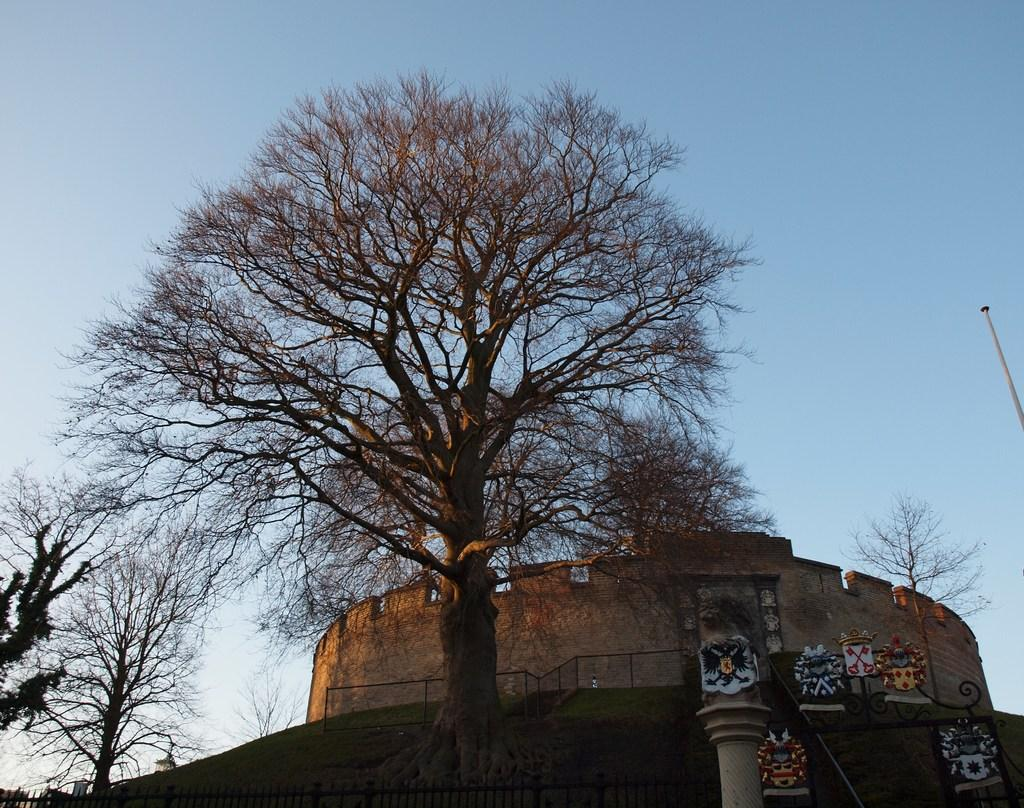What can be seen in the foreground of the image? There are trees and a monument in the foreground of the image. What is visible in the background of the image? The sky is visible in the background of the image. What type of rice can be seen growing near the monument in the image? There is no rice visible in the image; it features trees and a monument in the foreground, with the sky in the background. 